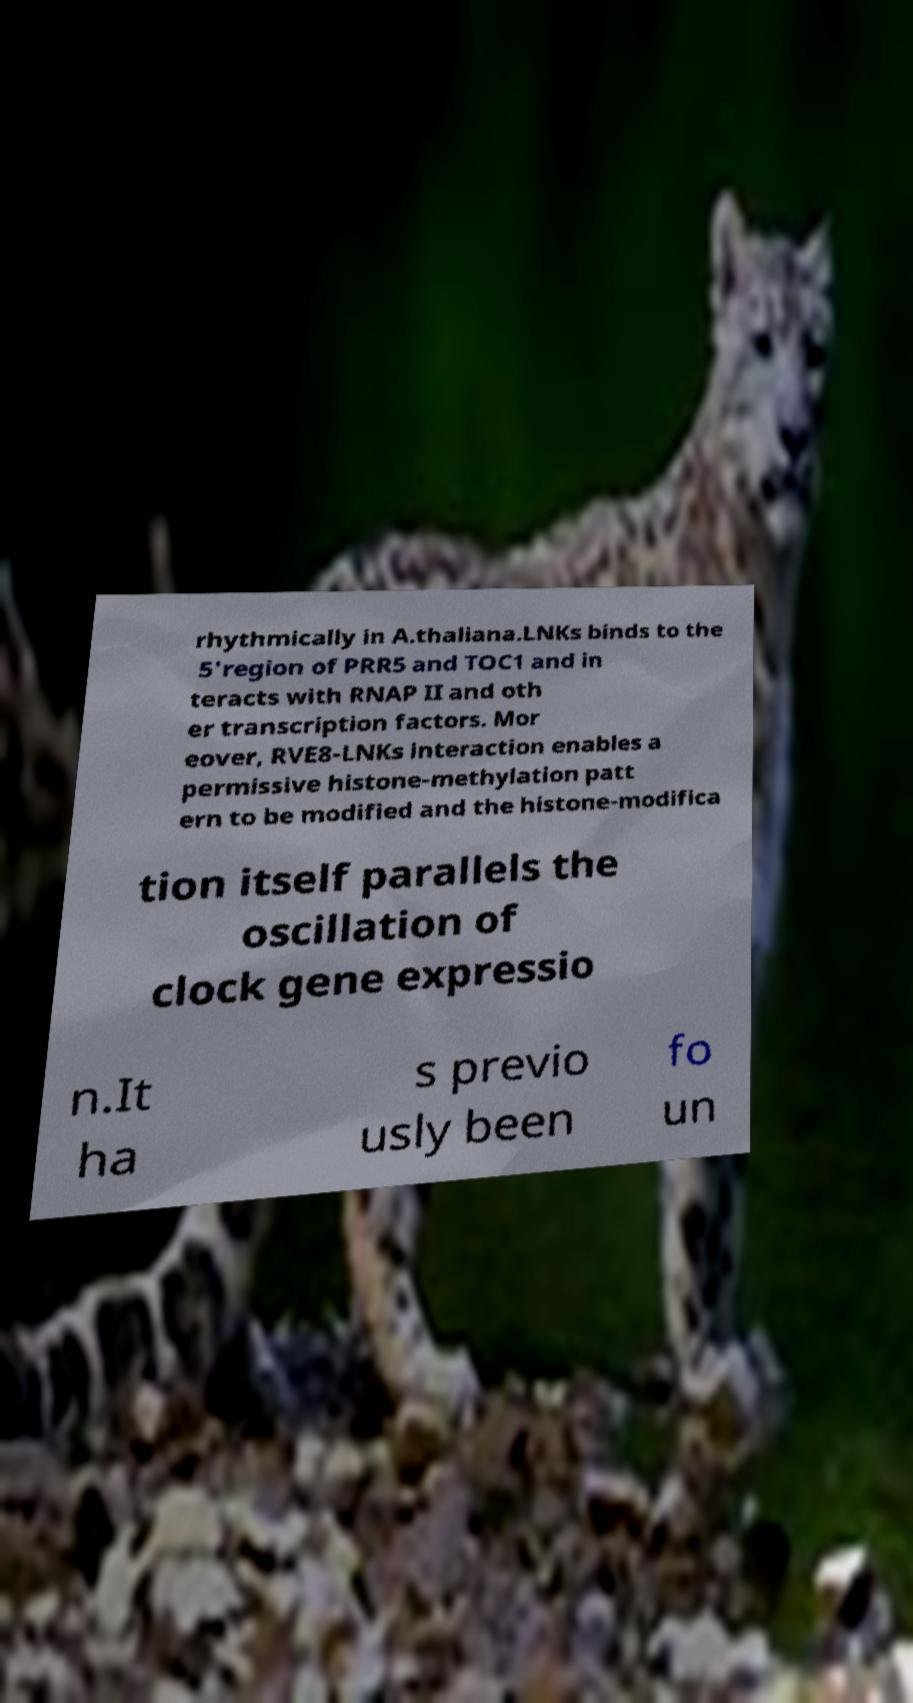For documentation purposes, I need the text within this image transcribed. Could you provide that? rhythmically in A.thaliana.LNKs binds to the 5'region of PRR5 and TOC1 and in teracts with RNAP II and oth er transcription factors. Mor eover, RVE8-LNKs interaction enables a permissive histone-methylation patt ern to be modified and the histone-modifica tion itself parallels the oscillation of clock gene expressio n.It ha s previo usly been fo un 